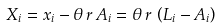Convert formula to latex. <formula><loc_0><loc_0><loc_500><loc_500>X _ { i } = x _ { i } - \theta \, r \, A _ { i } = \theta \, r \, \left ( L _ { i } - A _ { i } \right )</formula> 